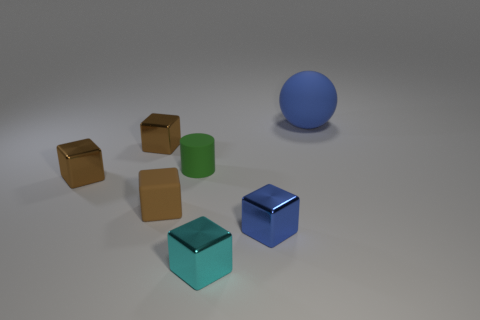Is there a block that has the same color as the large thing?
Give a very brief answer. Yes. What is the size of the shiny thing that is both on the right side of the matte cylinder and behind the tiny cyan block?
Make the answer very short. Small. The rubber thing that is the same size as the cylinder is what color?
Ensure brevity in your answer.  Brown. What number of objects are small cubes that are behind the tiny blue cube or tiny things that are right of the brown matte object?
Keep it short and to the point. 6. Are there the same number of tiny brown cubes in front of the brown rubber object and brown rubber things?
Your response must be concise. No. Do the metallic object that is to the right of the cyan metal object and the brown metal cube in front of the green thing have the same size?
Your answer should be compact. Yes. What number of other things are the same size as the blue rubber object?
Ensure brevity in your answer.  0. There is a blue object that is behind the blue object that is in front of the sphere; are there any small green things that are behind it?
Offer a very short reply. No. Is there any other thing that is the same color as the small matte cylinder?
Give a very brief answer. No. There is a object on the right side of the tiny blue object; what is its size?
Your answer should be compact. Large. 